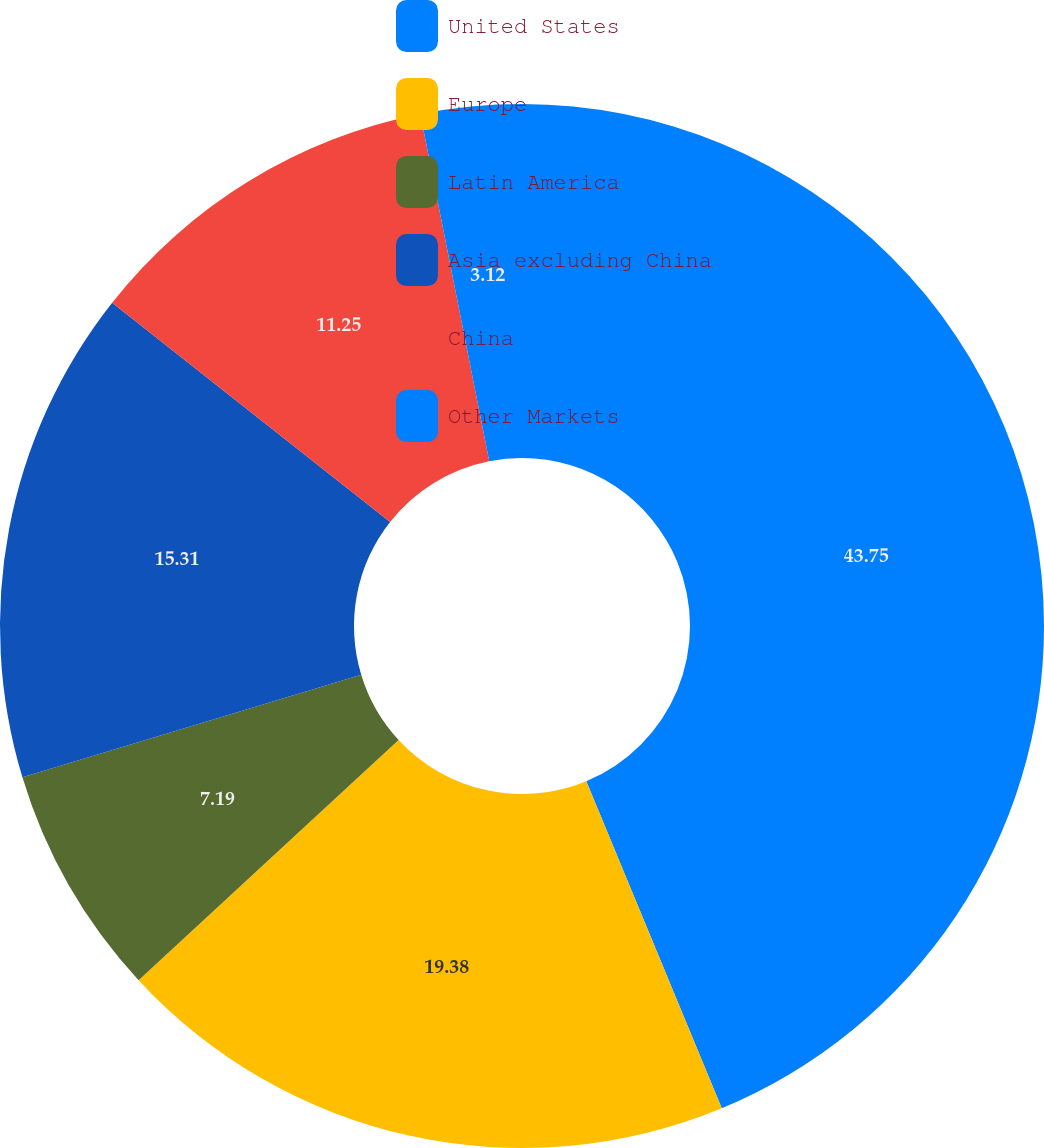Convert chart. <chart><loc_0><loc_0><loc_500><loc_500><pie_chart><fcel>United States<fcel>Europe<fcel>Latin America<fcel>Asia excluding China<fcel>China<fcel>Other Markets<nl><fcel>43.75%<fcel>19.38%<fcel>7.19%<fcel>15.31%<fcel>11.25%<fcel>3.12%<nl></chart> 